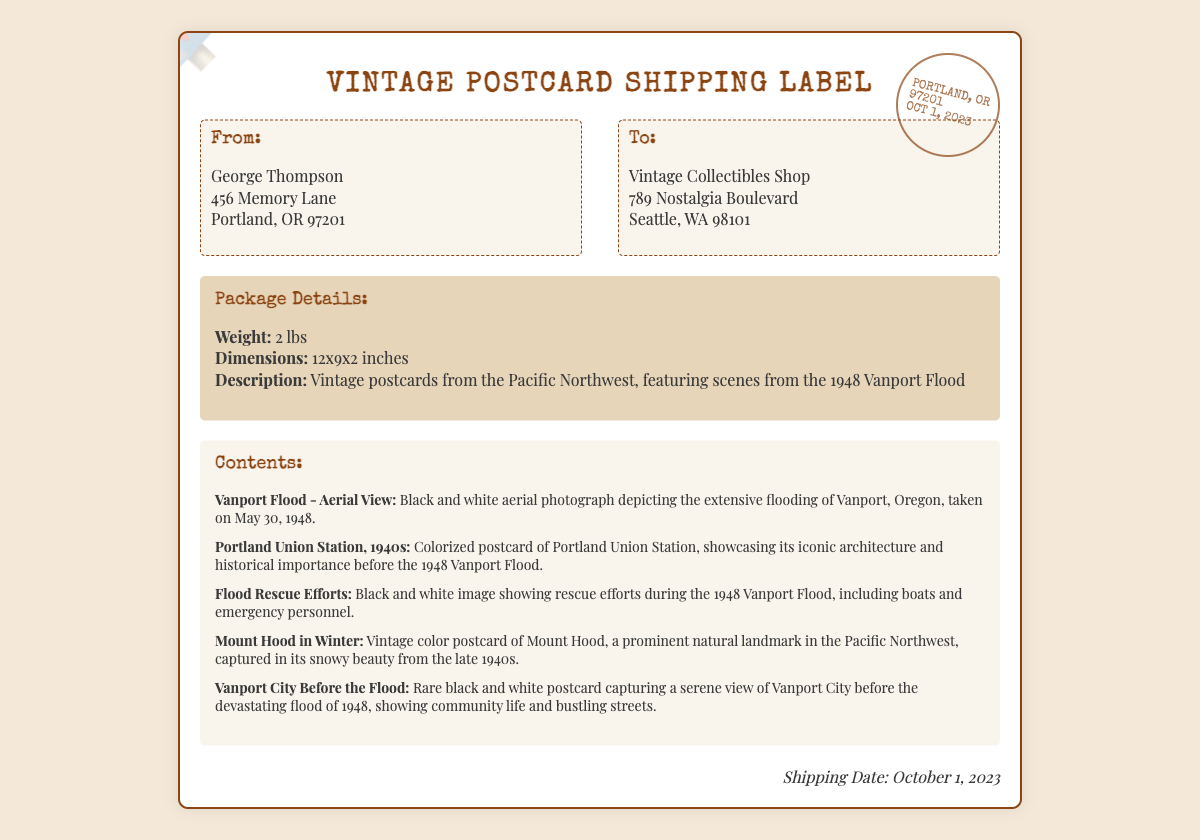what is the weight of the package? The weight is specified in the package details section of the document, which is 2 lbs.
Answer: 2 lbs who is the sender of the package? The sender's information is listed in the "From" section, where George Thompson is mentioned.
Answer: George Thompson what is the shipping date? The shipping date is noted at the bottom of the document, which is October 1, 2023.
Answer: October 1, 2023 what city is the recipient located in? The recipient's address shows that they are located in Seattle, WA.
Answer: Seattle how many vintage postcards are listed in the contents? The contents section lists five distinct items.
Answer: Five what type of images are included in the vintage postcards? The description in the contents section indicates that there are both black and white and color postcards featured.
Answer: Black and white, color which landmark is featured in one of the postcards? The contents mention Mount Hood as a prominent natural landmark depicted in one of the postcards.
Answer: Mount Hood what is the title of the aerial photograph postcard? The specific title mentioned for the aerial photograph is "Vanport Flood - Aerial View."
Answer: Vanport Flood - Aerial View what is the recipient's street address? The recipient's street address is detailed in the "To" section of the document, which is 789 Nostalgia Boulevard.
Answer: 789 Nostalgia Boulevard 